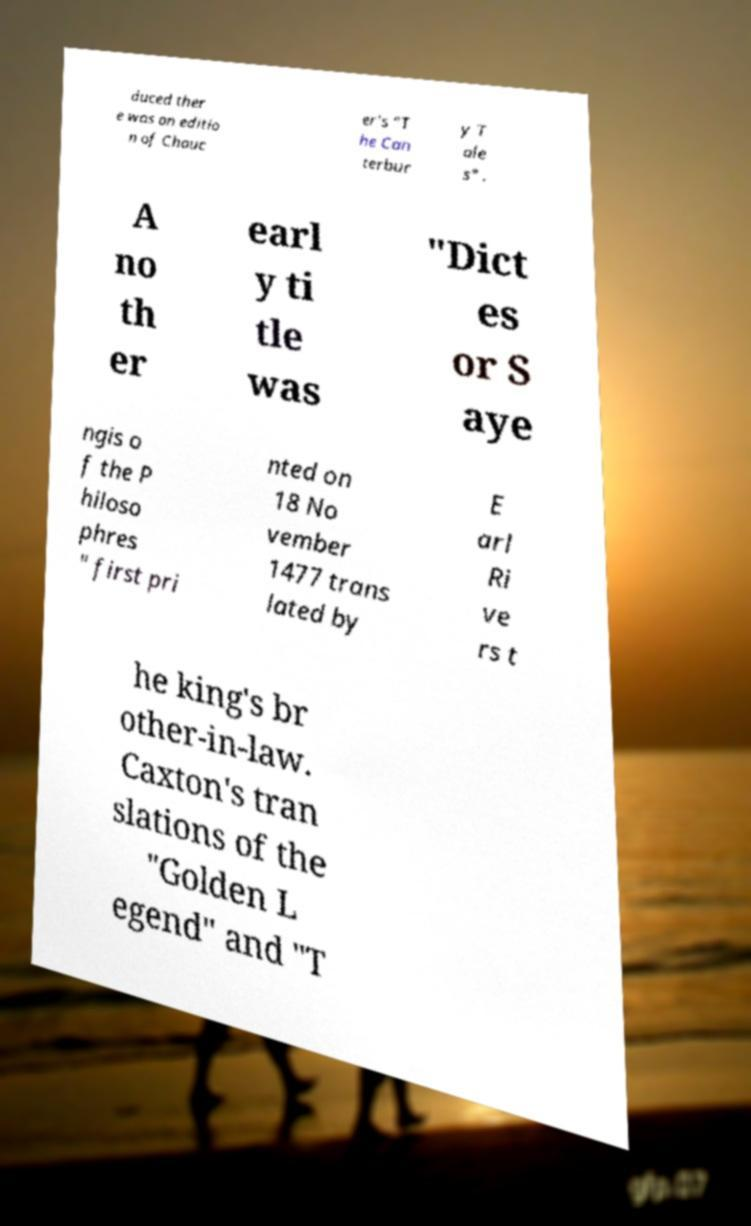What messages or text are displayed in this image? I need them in a readable, typed format. duced ther e was an editio n of Chauc er's "T he Can terbur y T ale s" . A no th er earl y ti tle was "Dict es or S aye ngis o f the P hiloso phres " first pri nted on 18 No vember 1477 trans lated by E arl Ri ve rs t he king's br other-in-law. Caxton's tran slations of the "Golden L egend" and "T 